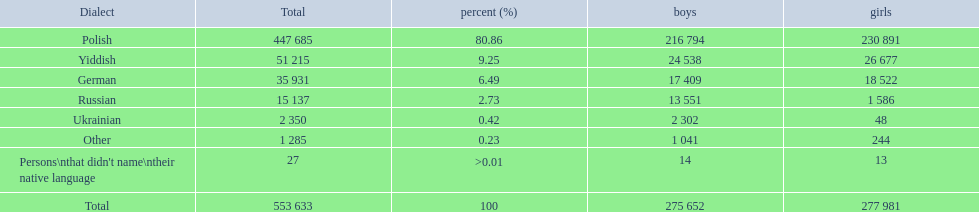Which language did the most people in the imperial census of 1897 speak in the p&#322;ock governorate? Polish. 